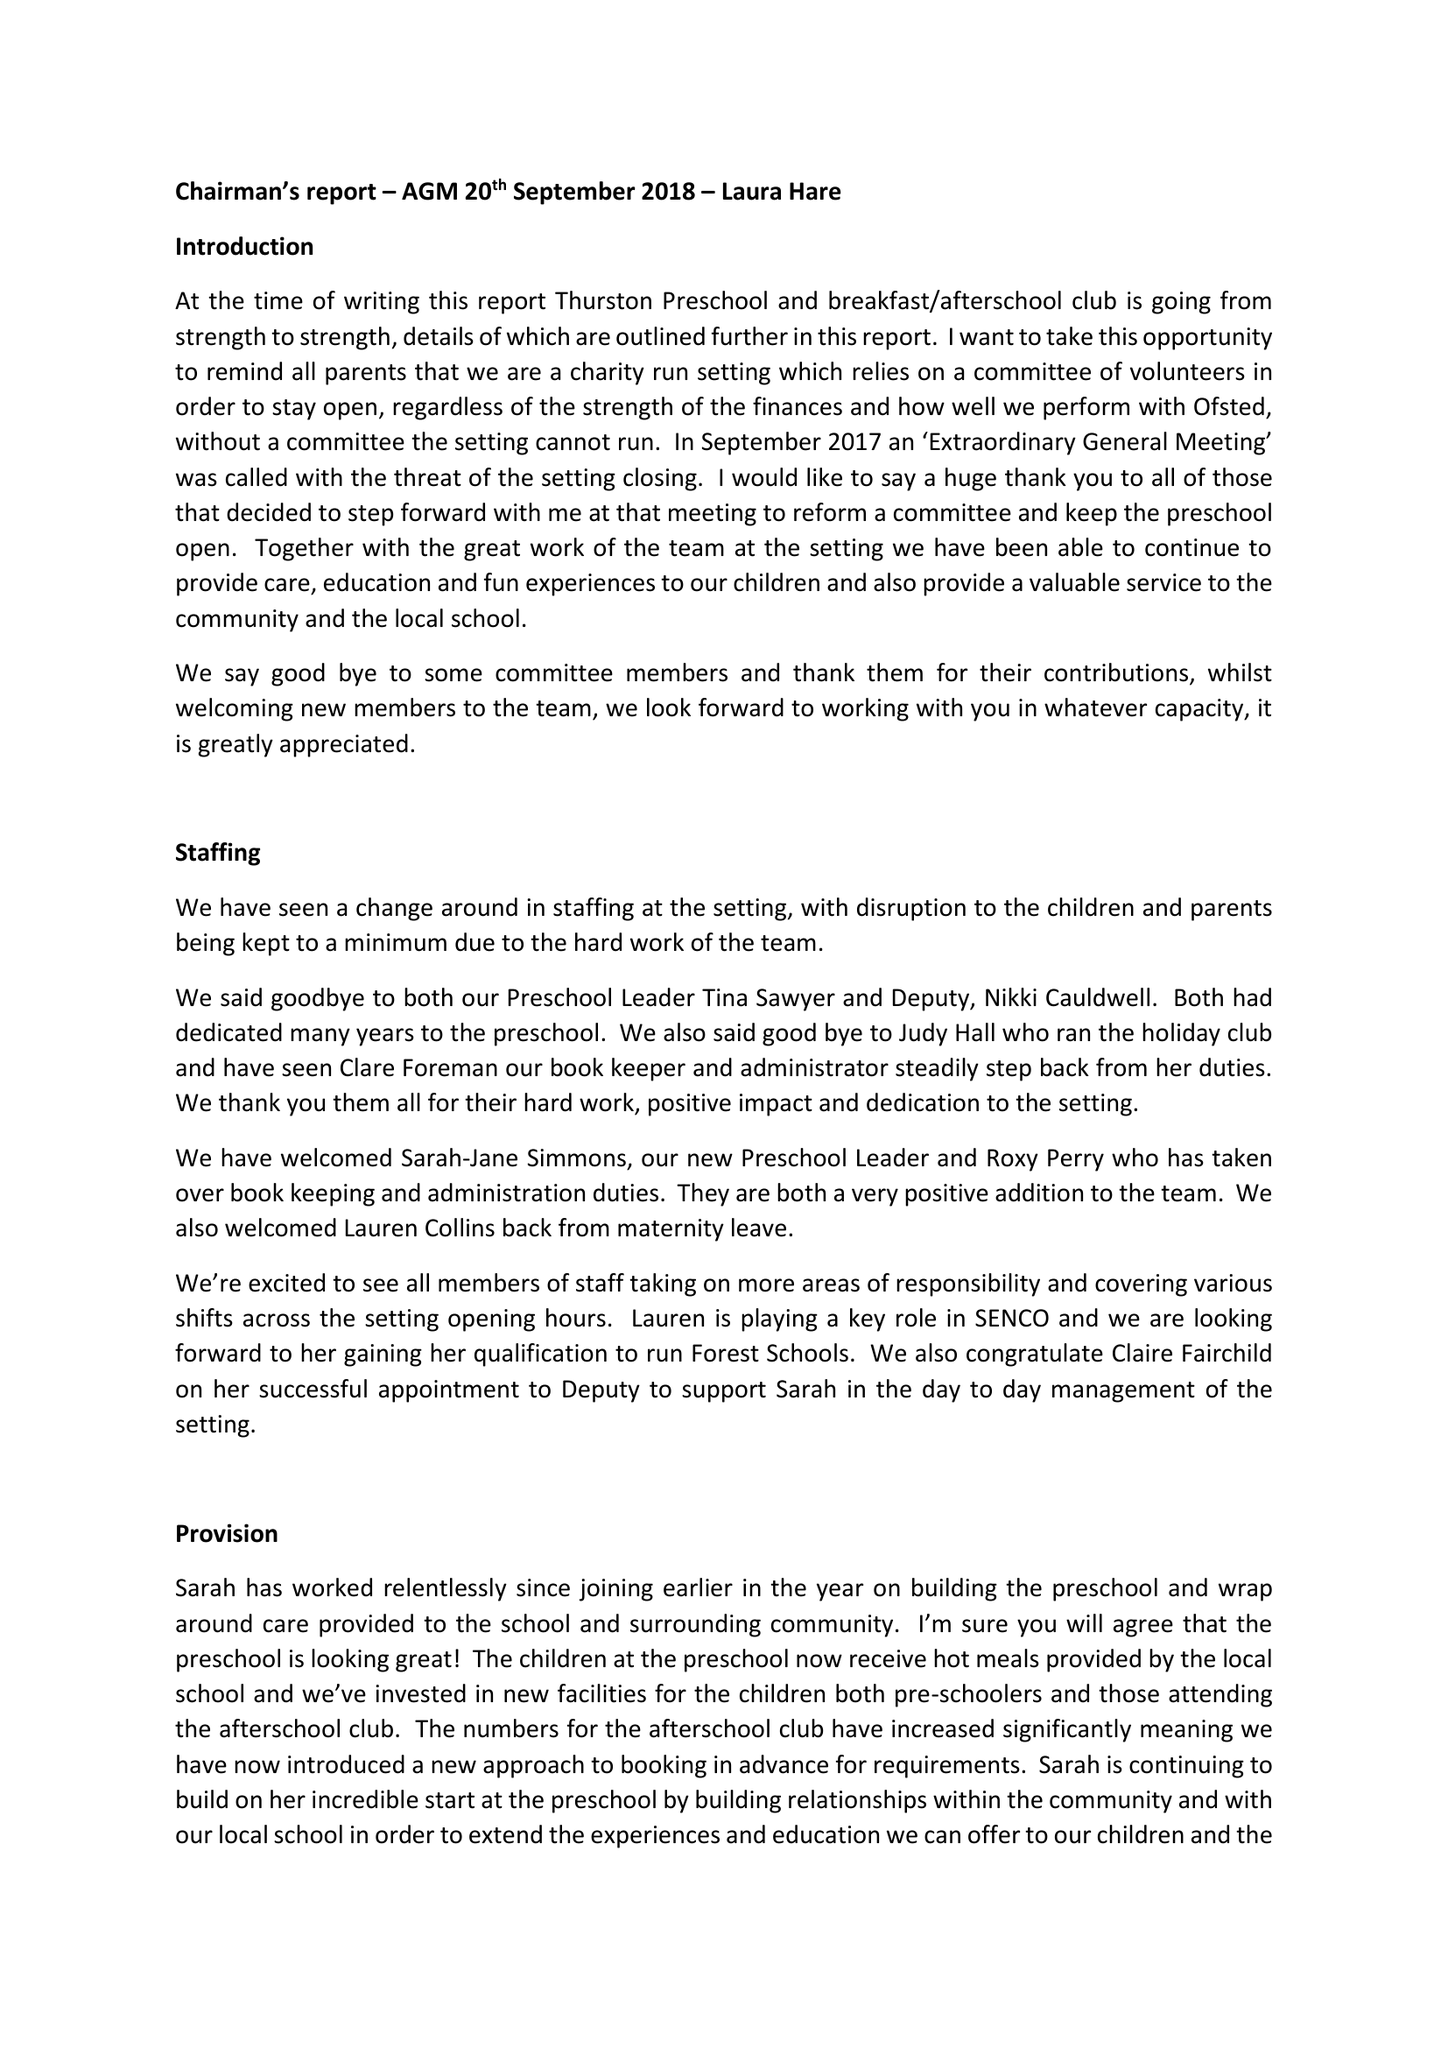What is the value for the address__street_line?
Answer the question using a single word or phrase. CHURCH ROAD 